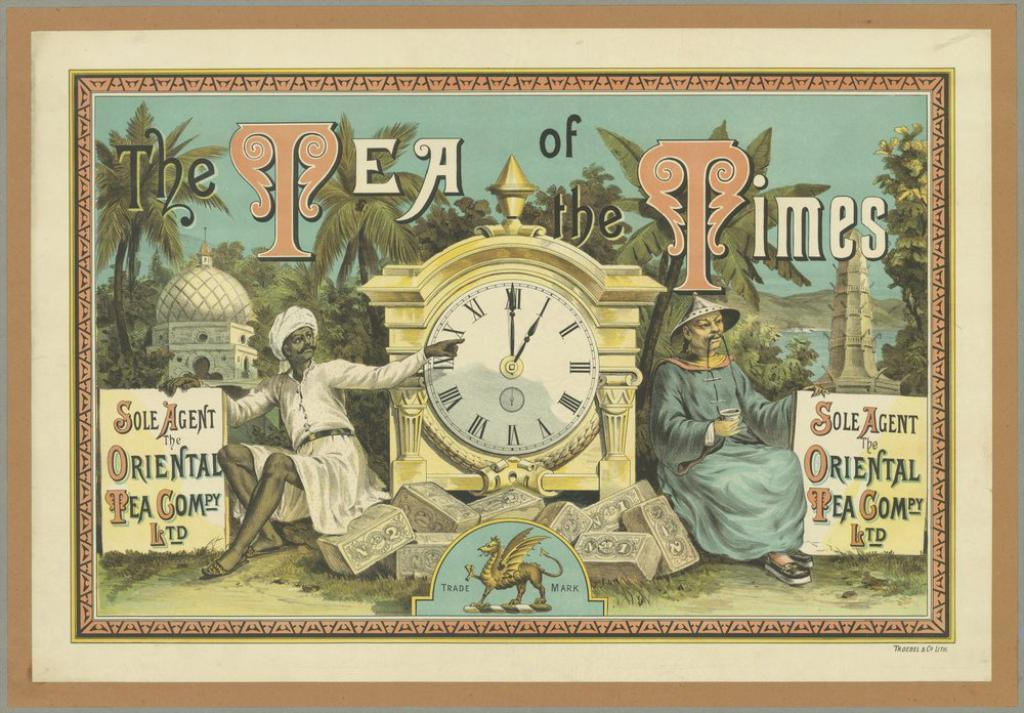<image>
Present a compact description of the photo's key features. Picture framed on a wall which says "The Tea of the Times". 